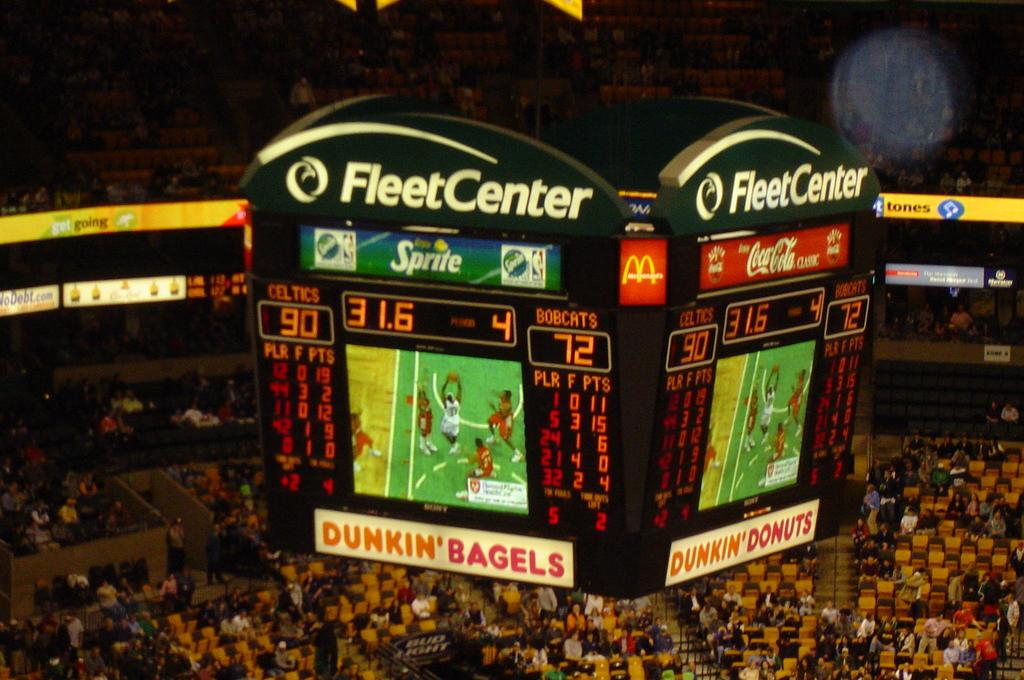<image>
Summarize the visual content of the image. Scoreboard at the FleetCenter which has an ad for Coca Cola. 